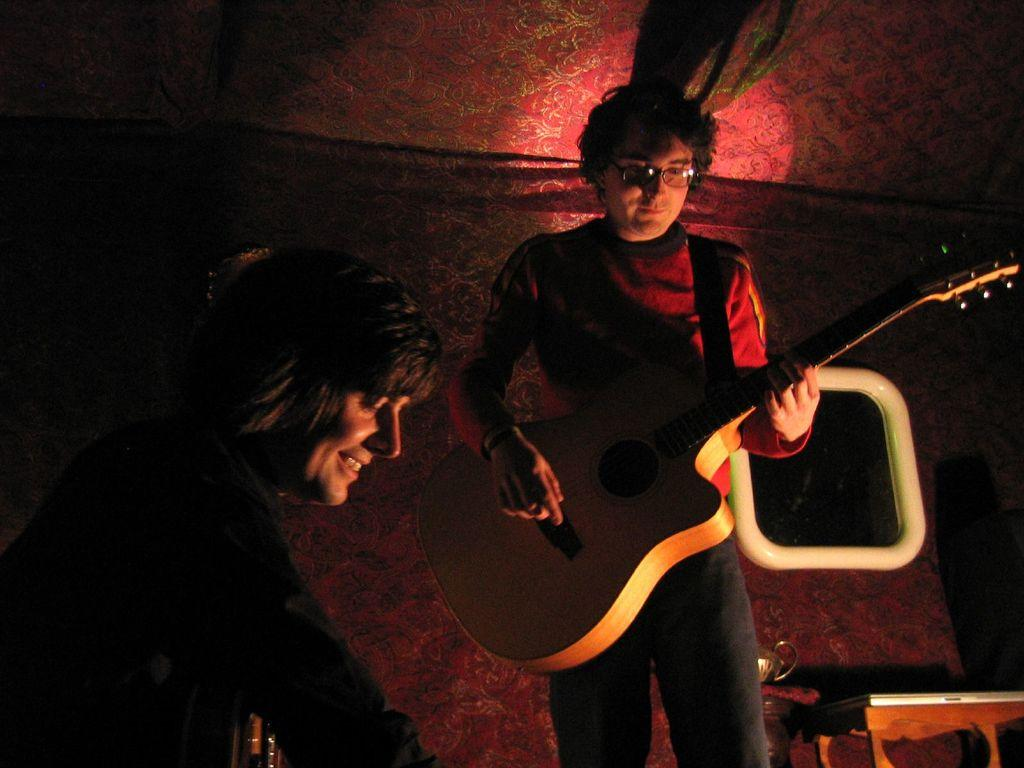How many people are in the image? There are two persons in the image. What is one of the persons holding? One of the persons is holding a guitar. Can you describe another object in the image? There is a mirror in the image. What type of wound can be seen on the guitar in the image? There is no wound present on the guitar in the image, as it is a musical instrument and not a living being. 